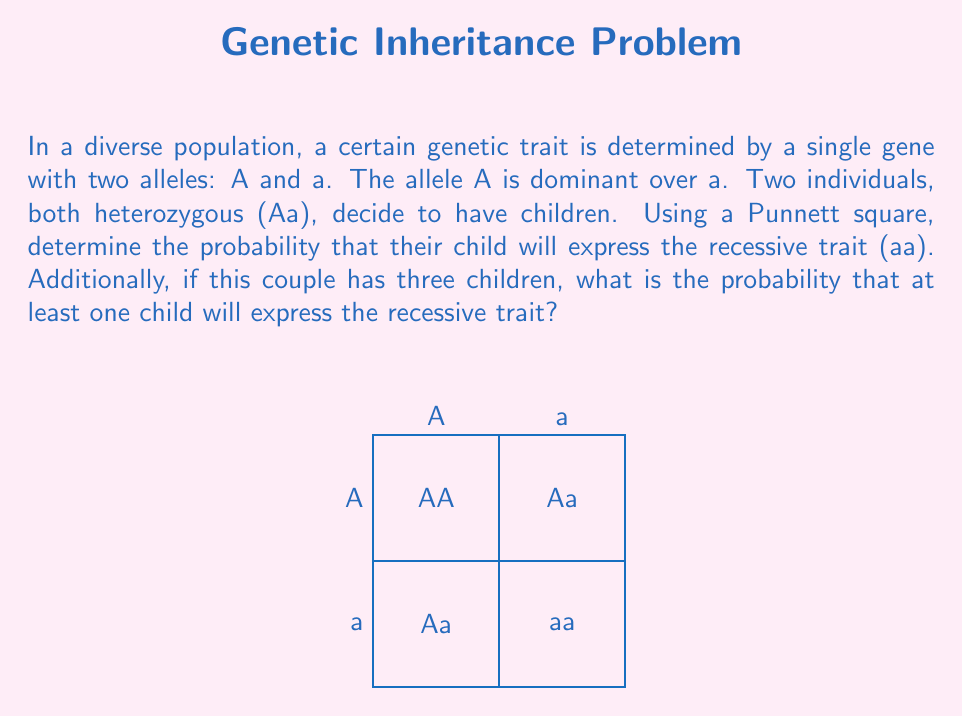Give your solution to this math problem. Let's approach this problem step-by-step:

1) First, we need to construct a Punnett square for two heterozygous parents (Aa x Aa):

   The Punnett square is shown in the question.

2) From the Punnett square, we can see that:
   - 1/4 of the offspring will be AA (homozygous dominant)
   - 2/4 = 1/2 of the offspring will be Aa (heterozygous)
   - 1/4 of the offspring will be aa (homozygous recessive)

3) The probability of a child expressing the recessive trait (aa) is 1/4 or 0.25 or 25%.

4) For the second part of the question, we need to find the probability of at least one child out of three expressing the recessive trait.

5) It's easier to calculate the probability of no children expressing the recessive trait and then subtract this from 1:

   P(at least one aa) = 1 - P(no aa)

6) The probability of a child not being aa is 3/4. For three children, we need this to happen three times independently:

   P(no aa) = $(3/4)^3 = 27/64 \approx 0.422$

7) Therefore, the probability of at least one child expressing the recessive trait is:

   P(at least one aa) = $1 - 27/64 = 37/64 \approx 0.578$ or about 57.8%
Answer: 0.25; 0.578 